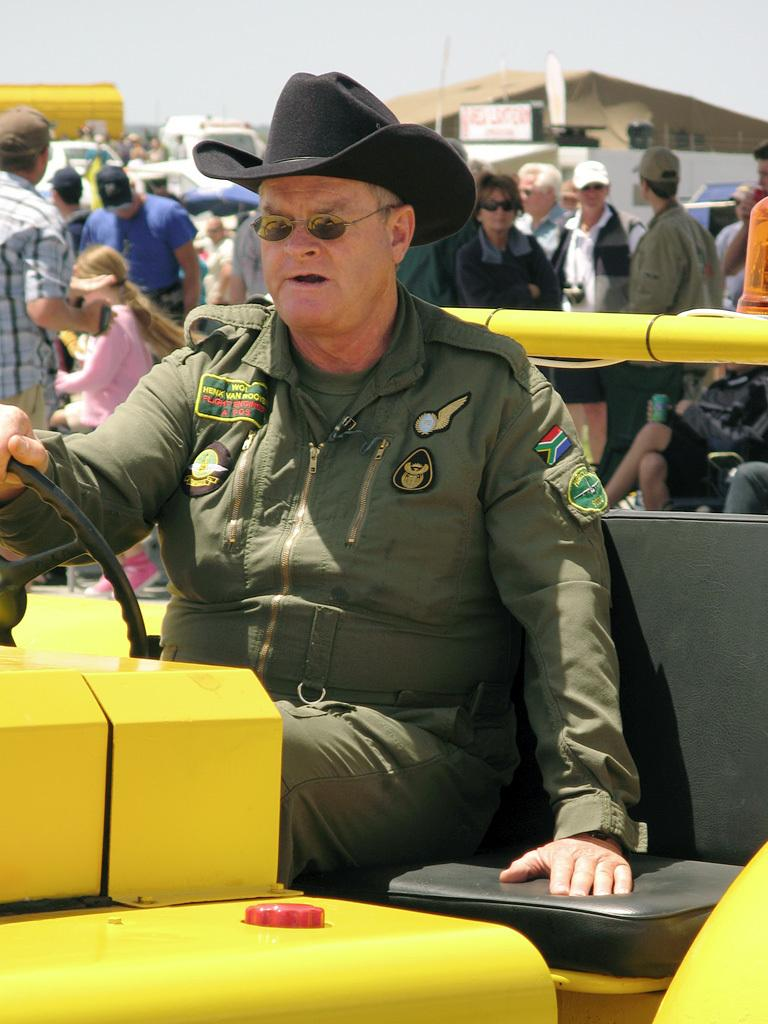What is the main subject of the image? The main subject of the image is a man sitting in a vehicle. Can you describe the man's appearance? The man is wearing a black color hat. What can be seen in the background of the image? There are persons, buildings, and cars in the background of the image. What type of paper is the man teaching in the image? There is no paper or teaching activity present in the image. What channel is the man watching on the vehicle's screen? The image does not show a screen or any indication of a channel being watched. 